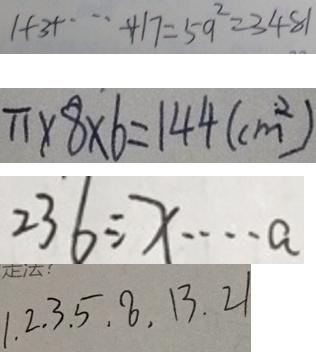<formula> <loc_0><loc_0><loc_500><loc_500>1 + 3 + \cdots + 1 7 = 5 9 ^ { 2 } = 3 4 8 1 
 \pi \times 8 \times 6 = 1 4 4 ( c m ^ { 2 } ) 
 2 3 6 \div x \cdots a 
 1 . 2 . 3 . 5 . 8 . 1 3 . 2 1</formula> 